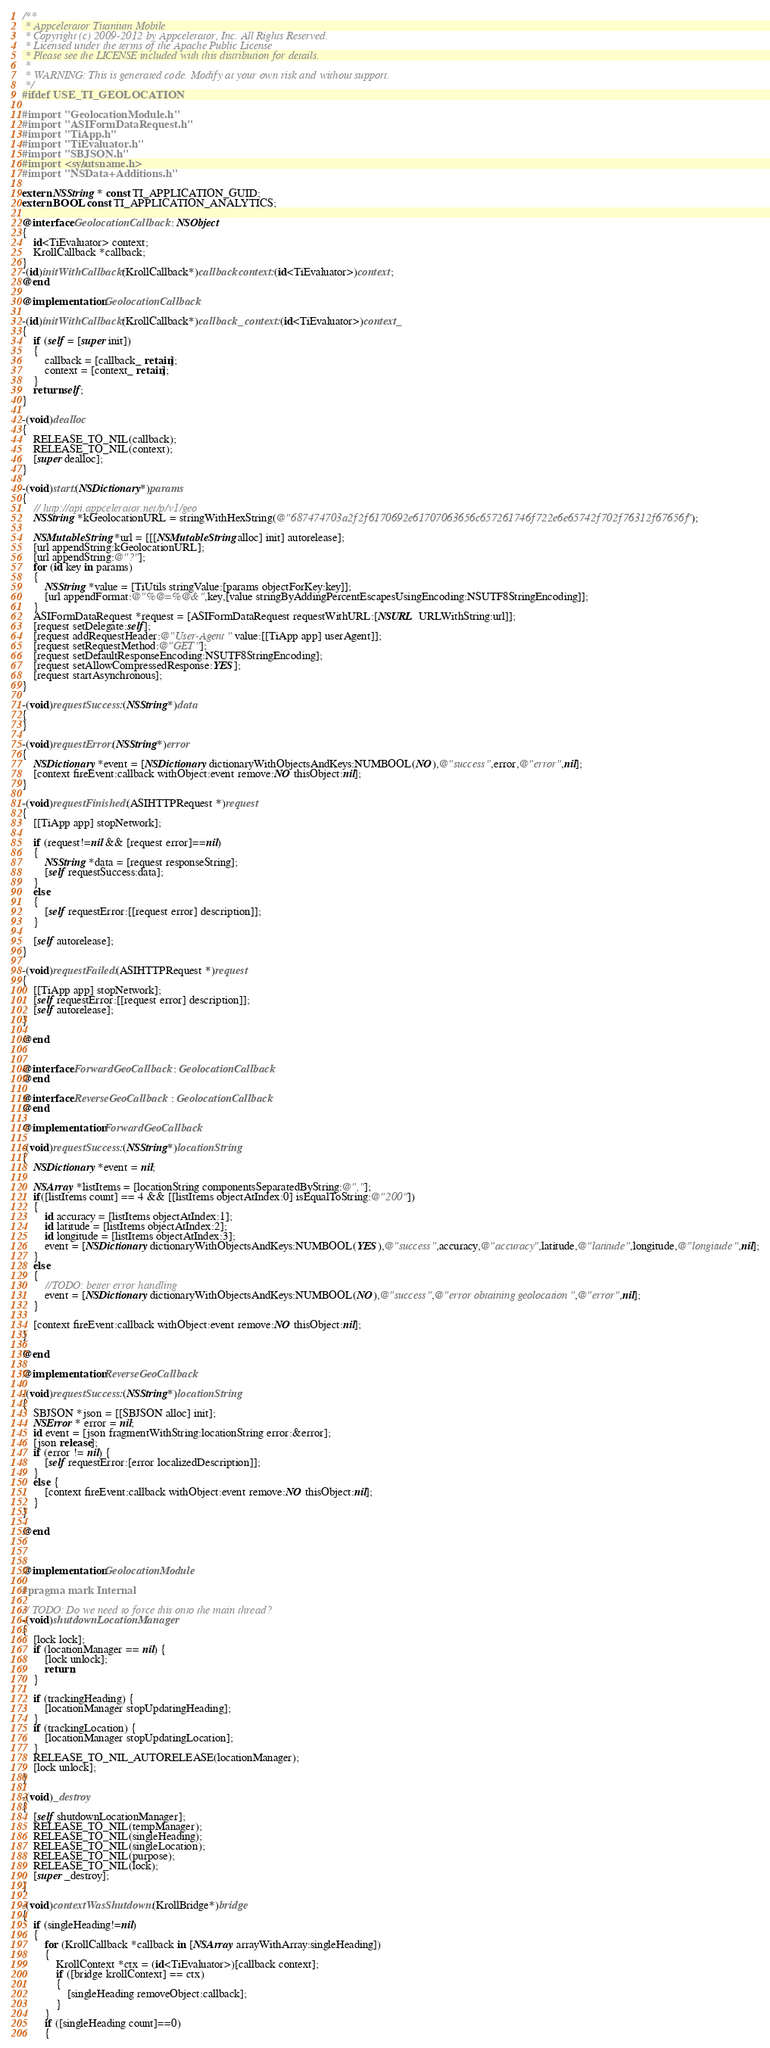Convert code to text. <code><loc_0><loc_0><loc_500><loc_500><_ObjectiveC_>/**
 * Appcelerator Titanium Mobile
 * Copyright (c) 2009-2012 by Appcelerator, Inc. All Rights Reserved.
 * Licensed under the terms of the Apache Public License
 * Please see the LICENSE included with this distribution for details.
 * 
 * WARNING: This is generated code. Modify at your own risk and without support.
 */
#ifdef USE_TI_GEOLOCATION

#import "GeolocationModule.h"
#import "ASIFormDataRequest.h"
#import "TiApp.h"
#import "TiEvaluator.h"
#import "SBJSON.h"
#import <sys/utsname.h>
#import "NSData+Additions.h"

extern NSString * const TI_APPLICATION_GUID;
extern BOOL const TI_APPLICATION_ANALYTICS;

@interface GeolocationCallback : NSObject
{
	id<TiEvaluator> context;
	KrollCallback *callback;
}
-(id)initWithCallback:(KrollCallback*)callback context:(id<TiEvaluator>)context;
@end

@implementation GeolocationCallback

-(id)initWithCallback:(KrollCallback*)callback_ context:(id<TiEvaluator>)context_
{
	if (self = [super init])
	{
		callback = [callback_ retain];
		context = [context_ retain];
	}
	return self;
}

-(void)dealloc
{
	RELEASE_TO_NIL(callback);
	RELEASE_TO_NIL(context);
	[super dealloc];
}

-(void)start:(NSDictionary*)params
{
	// http://api.appcelerator.net/p/v1/geo
	NSString *kGeolocationURL = stringWithHexString(@"687474703a2f2f6170692e61707063656c657261746f722e6e65742f702f76312f67656f");
	
	NSMutableString *url = [[[NSMutableString alloc] init] autorelease];
	[url appendString:kGeolocationURL];
	[url appendString:@"?"];
	for (id key in params)
	{
		NSString *value = [TiUtils stringValue:[params objectForKey:key]];
		[url appendFormat:@"%@=%@&",key,[value stringByAddingPercentEscapesUsingEncoding:NSUTF8StringEncoding]];
	}
	ASIFormDataRequest *request = [ASIFormDataRequest requestWithURL:[NSURL URLWithString:url]];	
	[request setDelegate:self];
	[request addRequestHeader:@"User-Agent" value:[[TiApp app] userAgent]];
	[request setRequestMethod:@"GET"];
	[request setDefaultResponseEncoding:NSUTF8StringEncoding];
	[request setAllowCompressedResponse:YES];
	[request startAsynchronous];
}

-(void)requestSuccess:(NSString*)data
{
}

-(void)requestError:(NSString*)error
{
	NSDictionary *event = [NSDictionary dictionaryWithObjectsAndKeys:NUMBOOL(NO),@"success",error,@"error",nil];
	[context fireEvent:callback withObject:event remove:NO thisObject:nil];
}

-(void)requestFinished:(ASIHTTPRequest *)request
{
	[[TiApp app] stopNetwork];

	if (request!=nil && [request error]==nil)
	{
		NSString *data = [request responseString];
		[self requestSuccess:data];
	}
	else 
	{
		[self requestError:[[request error] description]];
	}
	
	[self autorelease];
}

-(void)requestFailed:(ASIHTTPRequest *)request
{
	[[TiApp app] stopNetwork];
	[self requestError:[[request error] description]];
	[self autorelease];
}

@end


@interface ForwardGeoCallback : GeolocationCallback
@end

@interface ReverseGeoCallback : GeolocationCallback
@end

@implementation ForwardGeoCallback

-(void)requestSuccess:(NSString*)locationString
{
	NSDictionary *event = nil;
	
	NSArray *listItems = [locationString componentsSeparatedByString:@","];
	if([listItems count] == 4 && [[listItems objectAtIndex:0] isEqualToString:@"200"]) 
	{
		id accuracy = [listItems objectAtIndex:1];
		id latitude = [listItems objectAtIndex:2];
		id longitude = [listItems objectAtIndex:3];
		event = [NSDictionary dictionaryWithObjectsAndKeys:NUMBOOL(YES),@"success",accuracy,@"accuracy",latitude,@"latitude",longitude,@"longitude",nil];
	}
	else 
	{
		//TODO: better error handling
		event = [NSDictionary dictionaryWithObjectsAndKeys:NUMBOOL(NO),@"success",@"error obtaining geolocation",@"error",nil];
	}	
	
	[context fireEvent:callback withObject:event remove:NO thisObject:nil];
}

@end

@implementation ReverseGeoCallback

-(void)requestSuccess:(NSString*)locationString
{
	SBJSON *json = [[SBJSON alloc] init];
	NSError * error = nil;
	id event = [json fragmentWithString:locationString error:&error];
	[json release];
	if (error != nil) {
		[self requestError:[error localizedDescription]];
	}
	else {
		[context fireEvent:callback withObject:event remove:NO thisObject:nil];
	}
}

@end



@implementation GeolocationModule

#pragma mark Internal

// TODO: Do we need to force this onto the main thread?
-(void)shutdownLocationManager
{
	[lock lock];
	if (locationManager == nil) {
		[lock unlock];
		return;
	}
	
	if (trackingHeading) {
		[locationManager stopUpdatingHeading];
	}
	if (trackingLocation) {
		[locationManager stopUpdatingLocation];
	}
	RELEASE_TO_NIL_AUTORELEASE(locationManager);
	[lock unlock];
}

-(void)_destroy
{
	[self shutdownLocationManager];
	RELEASE_TO_NIL(tempManager);
	RELEASE_TO_NIL(singleHeading);
	RELEASE_TO_NIL(singleLocation);
	RELEASE_TO_NIL(purpose);
	RELEASE_TO_NIL(lock);
	[super _destroy];
}

-(void)contextWasShutdown:(KrollBridge*)bridge
{
	if (singleHeading!=nil)
	{
		for (KrollCallback *callback in [NSArray arrayWithArray:singleHeading])
		{
			KrollContext *ctx = (id<TiEvaluator>)[callback context];
			if ([bridge krollContext] == ctx)
			{
				[singleHeading removeObject:callback];
			}
		}
		if ([singleHeading count]==0)
		{</code> 